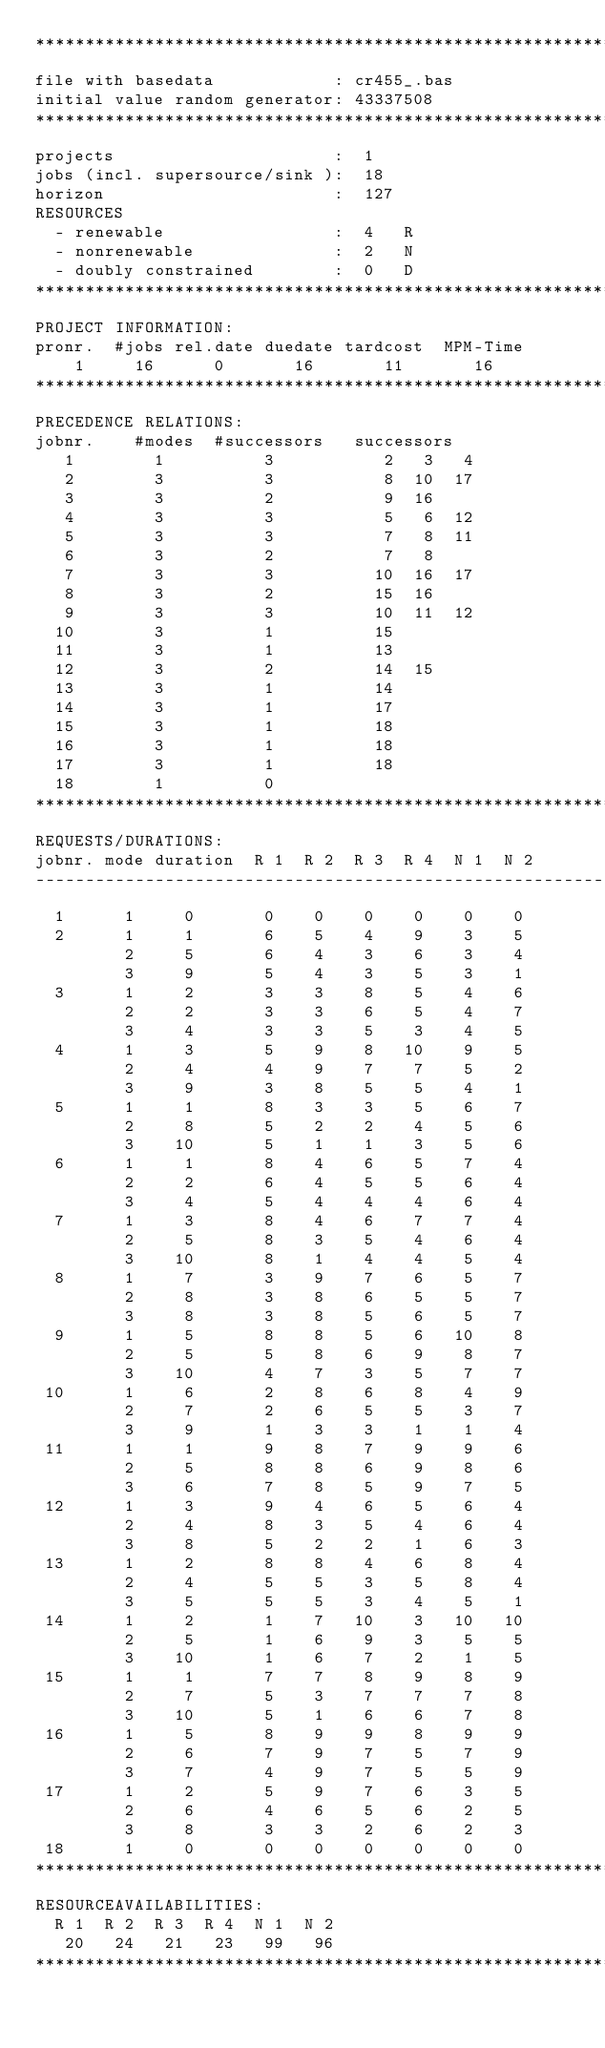Convert code to text. <code><loc_0><loc_0><loc_500><loc_500><_ObjectiveC_>************************************************************************
file with basedata            : cr455_.bas
initial value random generator: 43337508
************************************************************************
projects                      :  1
jobs (incl. supersource/sink ):  18
horizon                       :  127
RESOURCES
  - renewable                 :  4   R
  - nonrenewable              :  2   N
  - doubly constrained        :  0   D
************************************************************************
PROJECT INFORMATION:
pronr.  #jobs rel.date duedate tardcost  MPM-Time
    1     16      0       16       11       16
************************************************************************
PRECEDENCE RELATIONS:
jobnr.    #modes  #successors   successors
   1        1          3           2   3   4
   2        3          3           8  10  17
   3        3          2           9  16
   4        3          3           5   6  12
   5        3          3           7   8  11
   6        3          2           7   8
   7        3          3          10  16  17
   8        3          2          15  16
   9        3          3          10  11  12
  10        3          1          15
  11        3          1          13
  12        3          2          14  15
  13        3          1          14
  14        3          1          17
  15        3          1          18
  16        3          1          18
  17        3          1          18
  18        1          0        
************************************************************************
REQUESTS/DURATIONS:
jobnr. mode duration  R 1  R 2  R 3  R 4  N 1  N 2
------------------------------------------------------------------------
  1      1     0       0    0    0    0    0    0
  2      1     1       6    5    4    9    3    5
         2     5       6    4    3    6    3    4
         3     9       5    4    3    5    3    1
  3      1     2       3    3    8    5    4    6
         2     2       3    3    6    5    4    7
         3     4       3    3    5    3    4    5
  4      1     3       5    9    8   10    9    5
         2     4       4    9    7    7    5    2
         3     9       3    8    5    5    4    1
  5      1     1       8    3    3    5    6    7
         2     8       5    2    2    4    5    6
         3    10       5    1    1    3    5    6
  6      1     1       8    4    6    5    7    4
         2     2       6    4    5    5    6    4
         3     4       5    4    4    4    6    4
  7      1     3       8    4    6    7    7    4
         2     5       8    3    5    4    6    4
         3    10       8    1    4    4    5    4
  8      1     7       3    9    7    6    5    7
         2     8       3    8    6    5    5    7
         3     8       3    8    5    6    5    7
  9      1     5       8    8    5    6   10    8
         2     5       5    8    6    9    8    7
         3    10       4    7    3    5    7    7
 10      1     6       2    8    6    8    4    9
         2     7       2    6    5    5    3    7
         3     9       1    3    3    1    1    4
 11      1     1       9    8    7    9    9    6
         2     5       8    8    6    9    8    6
         3     6       7    8    5    9    7    5
 12      1     3       9    4    6    5    6    4
         2     4       8    3    5    4    6    4
         3     8       5    2    2    1    6    3
 13      1     2       8    8    4    6    8    4
         2     4       5    5    3    5    8    4
         3     5       5    5    3    4    5    1
 14      1     2       1    7   10    3   10   10
         2     5       1    6    9    3    5    5
         3    10       1    6    7    2    1    5
 15      1     1       7    7    8    9    8    9
         2     7       5    3    7    7    7    8
         3    10       5    1    6    6    7    8
 16      1     5       8    9    9    8    9    9
         2     6       7    9    7    5    7    9
         3     7       4    9    7    5    5    9
 17      1     2       5    9    7    6    3    5
         2     6       4    6    5    6    2    5
         3     8       3    3    2    6    2    3
 18      1     0       0    0    0    0    0    0
************************************************************************
RESOURCEAVAILABILITIES:
  R 1  R 2  R 3  R 4  N 1  N 2
   20   24   21   23   99   96
************************************************************************
</code> 